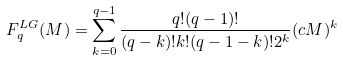Convert formula to latex. <formula><loc_0><loc_0><loc_500><loc_500>F _ { q } ^ { L G } ( M ) = \sum _ { k = 0 } ^ { q - 1 } \frac { q ! ( q - 1 ) ! } { ( q - k ) ! k ! ( q - 1 - k ) ! 2 ^ { k } } ( c M ) ^ { k }</formula> 